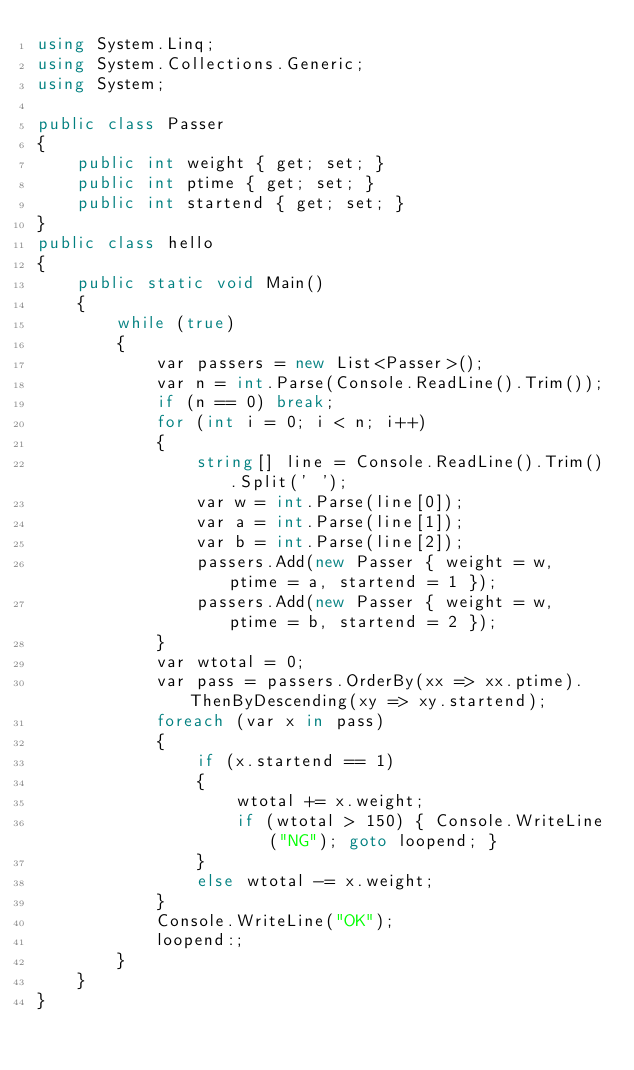<code> <loc_0><loc_0><loc_500><loc_500><_C#_>using System.Linq;
using System.Collections.Generic;
using System;

public class Passer
{
    public int weight { get; set; }
    public int ptime { get; set; }
    public int startend { get; set; }
}
public class hello
{
    public static void Main()
    {
        while (true)
        {
            var passers = new List<Passer>();
            var n = int.Parse(Console.ReadLine().Trim());
            if (n == 0) break;
            for (int i = 0; i < n; i++)
            {
                string[] line = Console.ReadLine().Trim().Split(' ');
                var w = int.Parse(line[0]);
                var a = int.Parse(line[1]);
                var b = int.Parse(line[2]);
                passers.Add(new Passer { weight = w, ptime = a, startend = 1 });
                passers.Add(new Passer { weight = w, ptime = b, startend = 2 });
            }
            var wtotal = 0;
            var pass = passers.OrderBy(xx => xx.ptime).ThenByDescending(xy => xy.startend);
            foreach (var x in pass) 
            {
                if (x.startend == 1)
                {
                    wtotal += x.weight;
                    if (wtotal > 150) { Console.WriteLine("NG"); goto loopend; }
                }
                else wtotal -= x.weight;
            }
            Console.WriteLine("OK");
            loopend:;
        }
    }
}</code> 